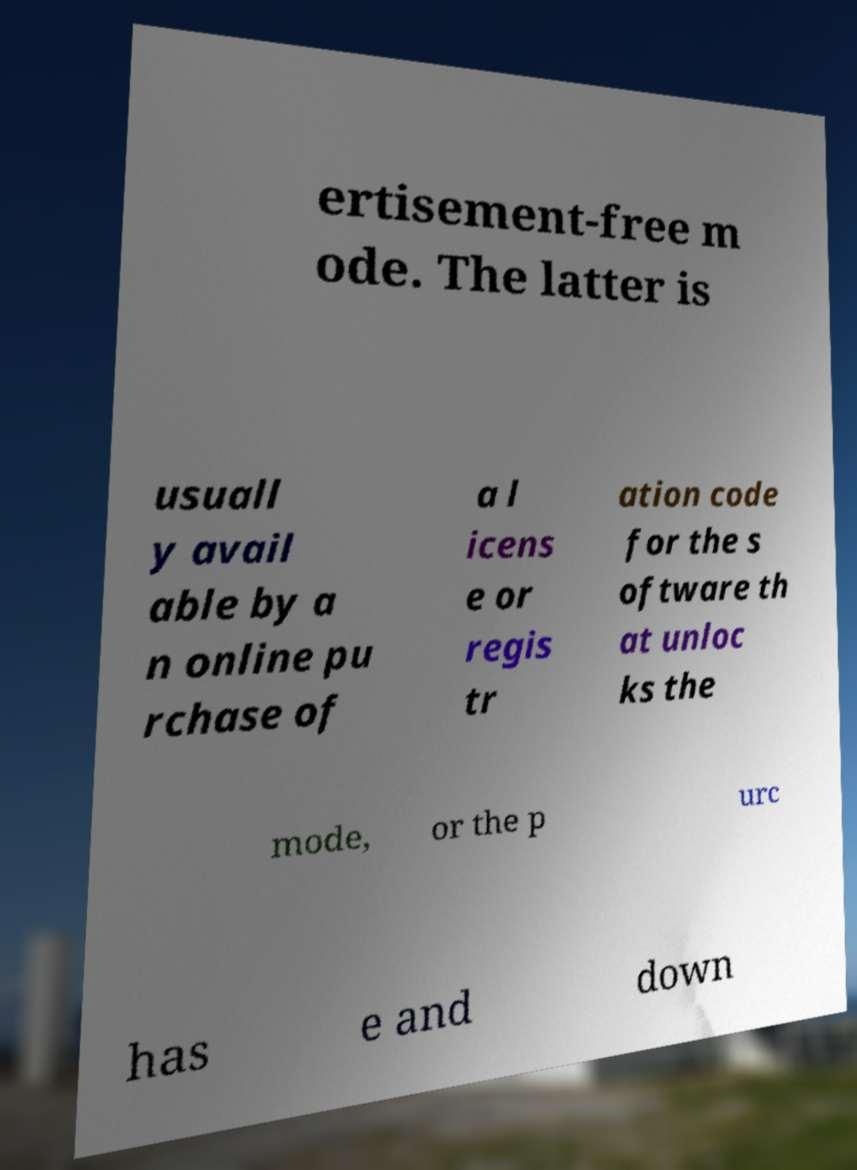For documentation purposes, I need the text within this image transcribed. Could you provide that? ertisement-free m ode. The latter is usuall y avail able by a n online pu rchase of a l icens e or regis tr ation code for the s oftware th at unloc ks the mode, or the p urc has e and down 